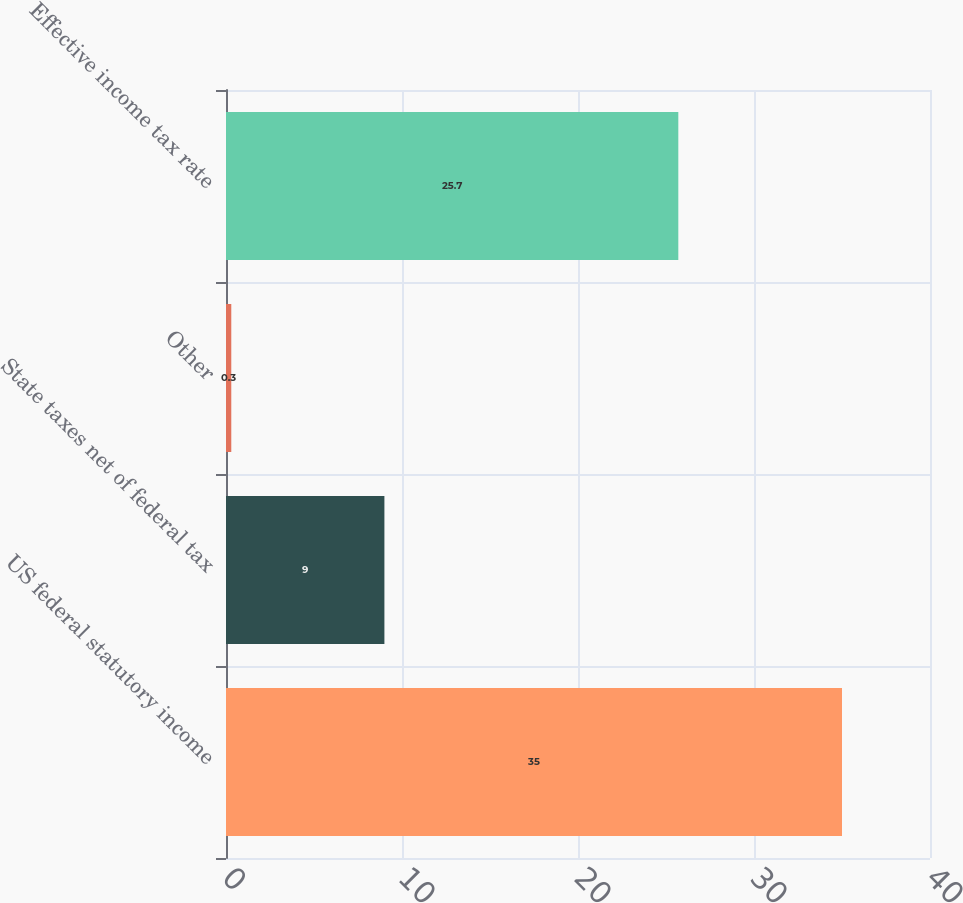<chart> <loc_0><loc_0><loc_500><loc_500><bar_chart><fcel>US federal statutory income<fcel>State taxes net of federal tax<fcel>Other<fcel>Effective income tax rate<nl><fcel>35<fcel>9<fcel>0.3<fcel>25.7<nl></chart> 